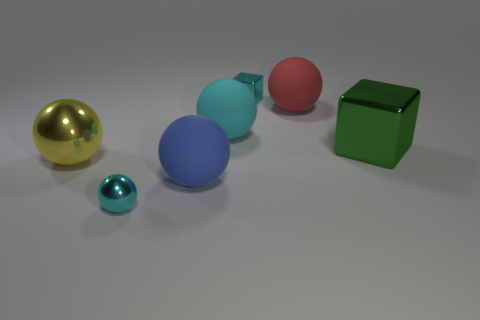Are there an equal number of shiny cubes that are on the right side of the big green shiny cube and tiny cyan balls that are behind the yellow sphere?
Offer a terse response. Yes. What shape is the object that is both to the left of the red thing and behind the large cyan sphere?
Provide a succinct answer. Cube. There is a green block; what number of shiny things are behind it?
Provide a short and direct response. 1. How many other objects are there of the same shape as the green metal thing?
Make the answer very short. 1. Are there fewer big shiny objects than red rubber spheres?
Your response must be concise. No. How big is the rubber ball that is behind the large yellow ball and on the left side of the red thing?
Your response must be concise. Large. There is a block behind the big ball that is right of the tiny cyan metal thing that is to the right of the small cyan metallic sphere; what is its size?
Your answer should be compact. Small. The red ball has what size?
Provide a short and direct response. Large. Are there any other things that have the same material as the yellow sphere?
Your response must be concise. Yes. There is a tiny cyan metallic object behind the large rubber thing that is in front of the yellow thing; are there any big green cubes that are behind it?
Keep it short and to the point. No. 